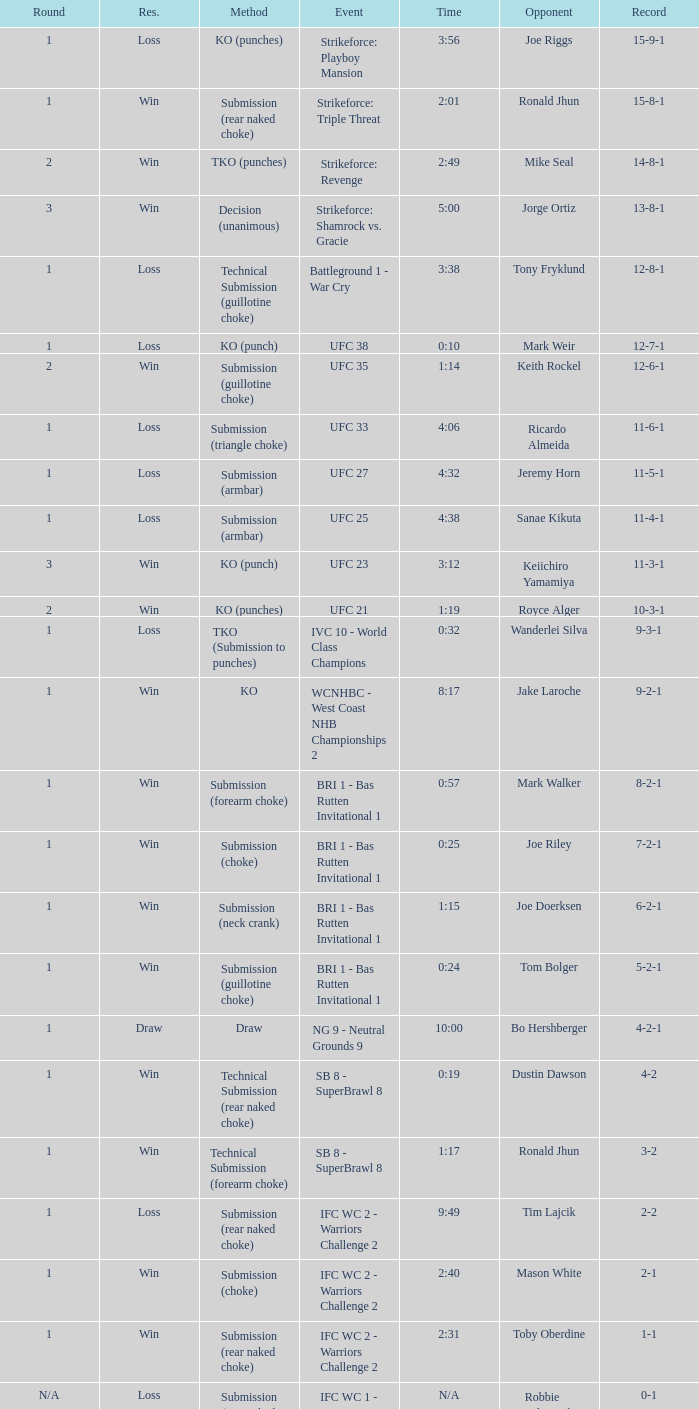Who was the opponent when the fight had a time of 2:01? Ronald Jhun. 